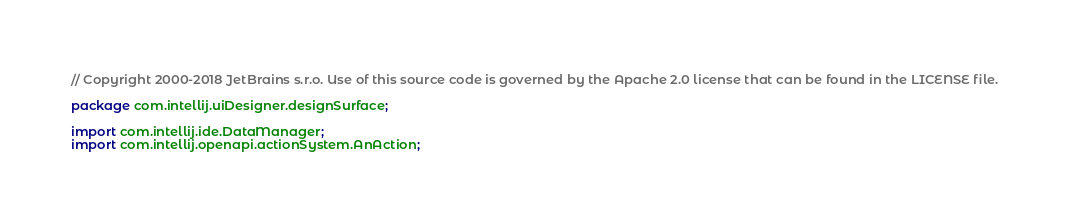Convert code to text. <code><loc_0><loc_0><loc_500><loc_500><_Java_>// Copyright 2000-2018 JetBrains s.r.o. Use of this source code is governed by the Apache 2.0 license that can be found in the LICENSE file.

package com.intellij.uiDesigner.designSurface;

import com.intellij.ide.DataManager;
import com.intellij.openapi.actionSystem.AnAction;</code> 